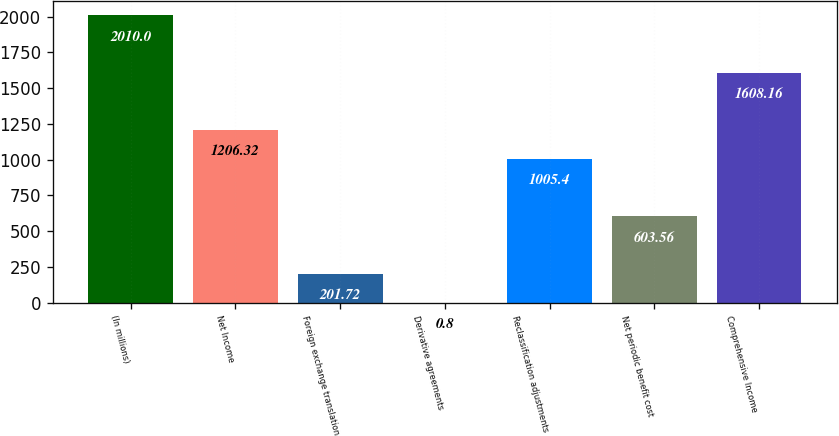<chart> <loc_0><loc_0><loc_500><loc_500><bar_chart><fcel>(In millions)<fcel>Net Income<fcel>Foreign exchange translation<fcel>Derivative agreements<fcel>Reclassification adjustments<fcel>Net periodic benefit cost<fcel>Comprehensive Income<nl><fcel>2010<fcel>1206.32<fcel>201.72<fcel>0.8<fcel>1005.4<fcel>603.56<fcel>1608.16<nl></chart> 